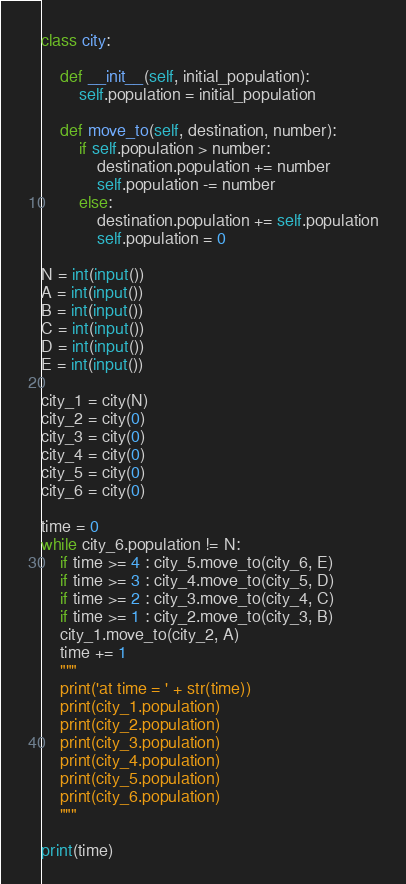Convert code to text. <code><loc_0><loc_0><loc_500><loc_500><_Python_>class city:
    
    def __init__(self, initial_population):
        self.population = initial_population
    
    def move_to(self, destination, number):
        if self.population > number:
            destination.population += number
            self.population -= number
        else:
            destination.population += self.population
            self.population = 0

N = int(input())
A = int(input())
B = int(input())
C = int(input())
D = int(input())
E = int(input())

city_1 = city(N)
city_2 = city(0)
city_3 = city(0)
city_4 = city(0)
city_5 = city(0)
city_6 = city(0)

time = 0
while city_6.population != N: 
    if time >= 4 : city_5.move_to(city_6, E)
    if time >= 3 : city_4.move_to(city_5, D)
    if time >= 2 : city_3.move_to(city_4, C)
    if time >= 1 : city_2.move_to(city_3, B)
    city_1.move_to(city_2, A)
    time += 1
    """
    print('at time = ' + str(time))
    print(city_1.population)
    print(city_2.population)
    print(city_3.population)
    print(city_4.population)
    print(city_5.population)
    print(city_6.population)
    """

print(time)</code> 